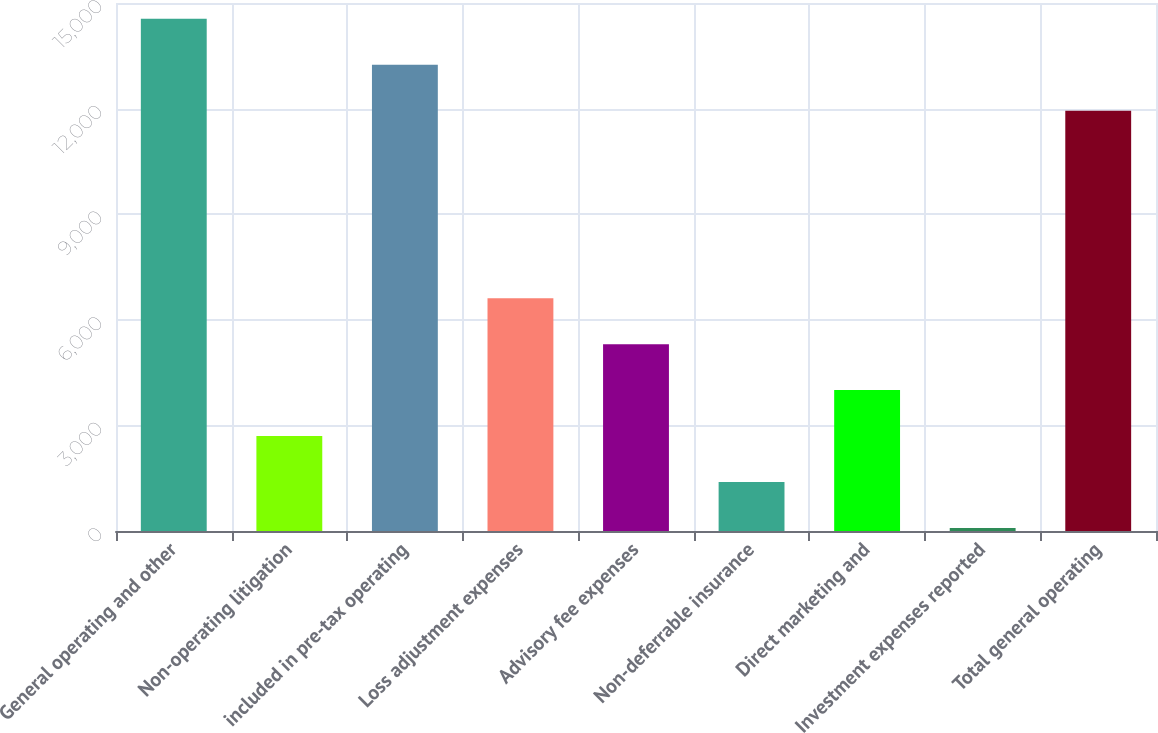Convert chart. <chart><loc_0><loc_0><loc_500><loc_500><bar_chart><fcel>General operating and other<fcel>Non-operating litigation<fcel>included in pre-tax operating<fcel>Loss adjustment expenses<fcel>Advisory fee expenses<fcel>Non-deferrable insurance<fcel>Direct marketing and<fcel>Investment expenses reported<fcel>Total general operating<nl><fcel>14550<fcel>2698<fcel>13245<fcel>6613<fcel>5308<fcel>1393<fcel>4003<fcel>88<fcel>11940<nl></chart> 